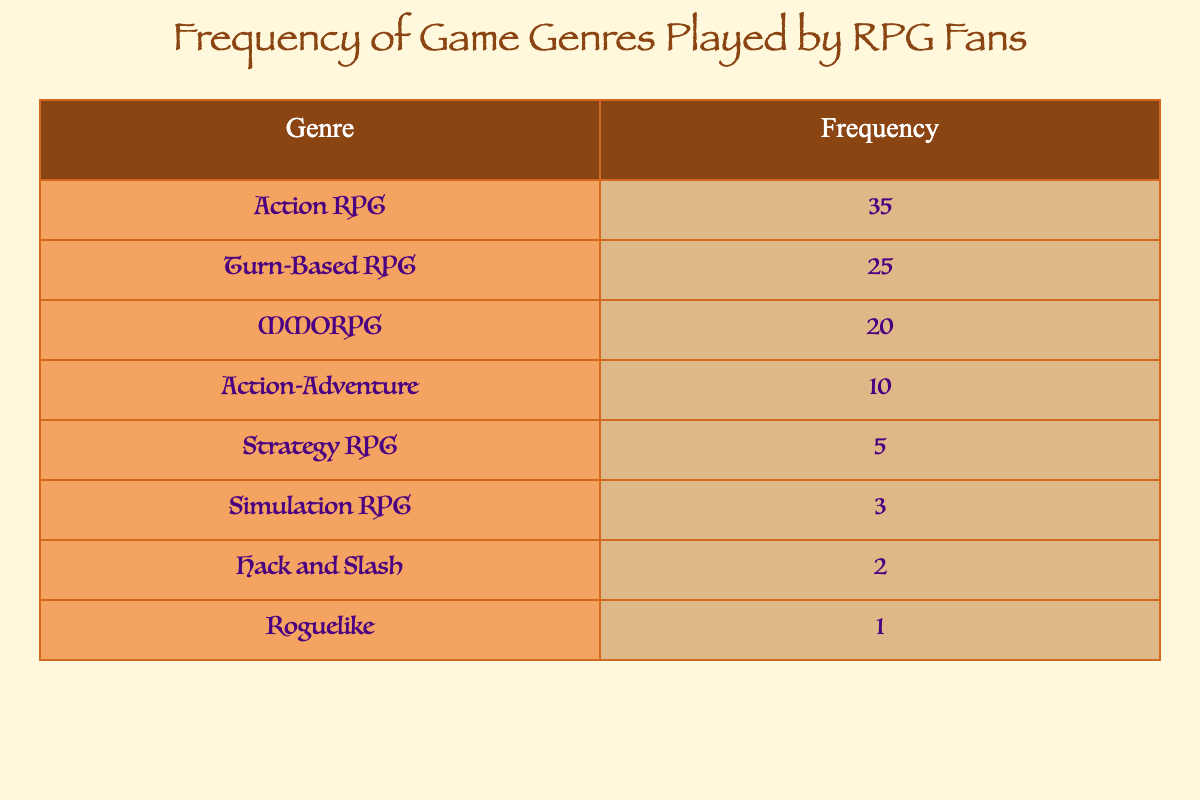What is the most popular game genre among RPG fans? The most popular genre can be found by looking at the highest frequency value in the table. The genre with the highest frequency is Action RPG with a frequency of 35.
Answer: Action RPG How many RPG fans play Turn-Based RPGs? The frequency of Turn-Based RPG is listed directly in the table, which shows there are 25 RPG fans who play this genre.
Answer: 25 Which genre has the lowest frequency? By inspecting the frequency values in the table, Roguelike has the lowest frequency at 1.
Answer: Roguelike What is the total frequency of MMORPG and Action-Adventure genres combined? To find the combined frequency, add the frequencies of MMORPG (20) and Action-Adventure (10): 20 + 10 = 30.
Answer: 30 Is the frequency of Simulation RPGs higher than that of Hack and Slash? To determine this, compare the frequencies: Simulation RPG has a frequency of 3, while Hack and Slash has a frequency of 2. Since 3 is greater than 2, the answer is yes.
Answer: Yes What is the average frequency of the top three game genres? First, identify the frequencies of the top three genres: Action RPG (35), Turn-Based RPG (25), and MMORPG (20). Then calculate the average: (35 + 25 + 20) / 3 = 80 / 3 = approximately 26.67.
Answer: Approximately 26.67 Are there more RPG fans who play Action RPGs than those who play the combination of Strategy RPG, Simulation RPG, and Hack and Slash genres? Calculate the total frequency of the three genres: Strategy RPG (5), Simulation RPG (3), and Hack and Slash (2), which sums up to 5 + 3 + 2 = 10. Since the frequency of Action RPG is 35, which is greater than 10, the answer is yes.
Answer: Yes What is the difference in frequency between Action RPGs and Turn-Based RPGs? To find the difference, subtract the frequency of Turn-Based RPG (25) from Action RPG (35): 35 - 25 = 10.
Answer: 10 What proportion of RPG fans play genres other than Action RPG? First, find the combined frequency of all other genres: Turn-Based RPG (25) + MMORPG (20) + Action-Adventure (10) + Strategy RPG (5) + Simulation RPG (3) + Hack and Slash (2) + Roguelike (1) = 66. The total frequency of all genres is 35 + 66 = 101. The proportion is 66 / 101 = approximately 0.6535, or about 65.35%.
Answer: Approximately 65.35% 